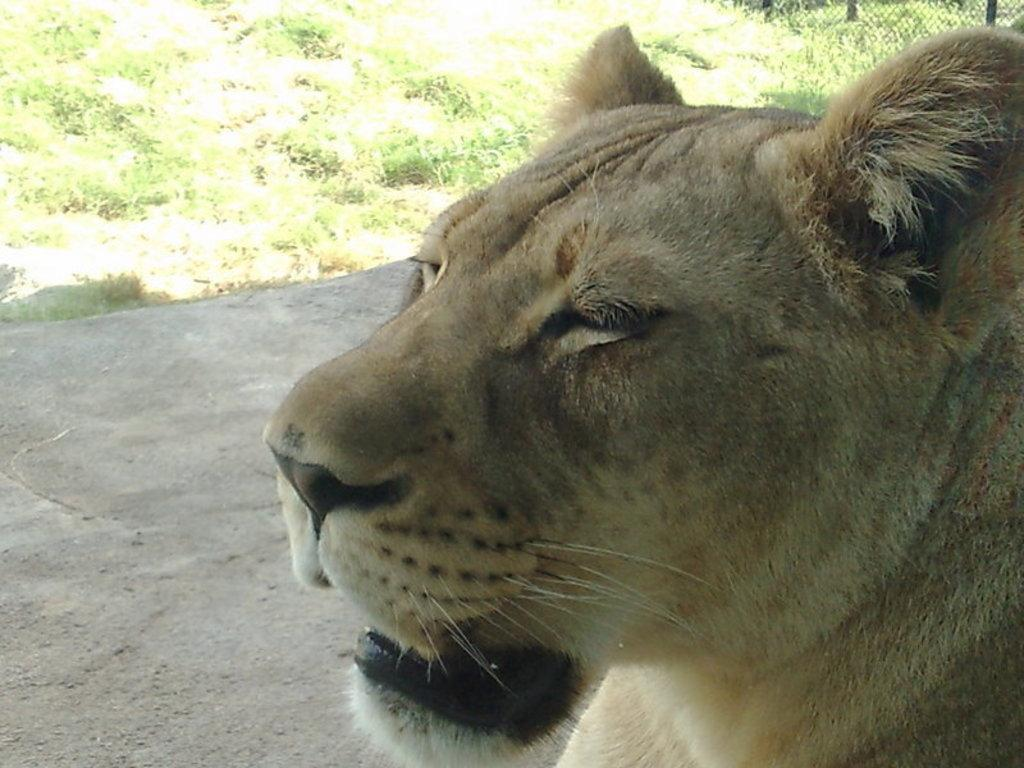What animal is in the picture? There is a lioness in the picture. What can be seen in the background of the picture? There is grass in the background of the picture. Where is the fencing located in the picture? The fencing is at the right top of the picture. Can you see the friend of the lioness in the picture? There is no friend of the lioness present in the image. Is there a cracker on the bed in the picture? There is no bed or cracker present in the image. 